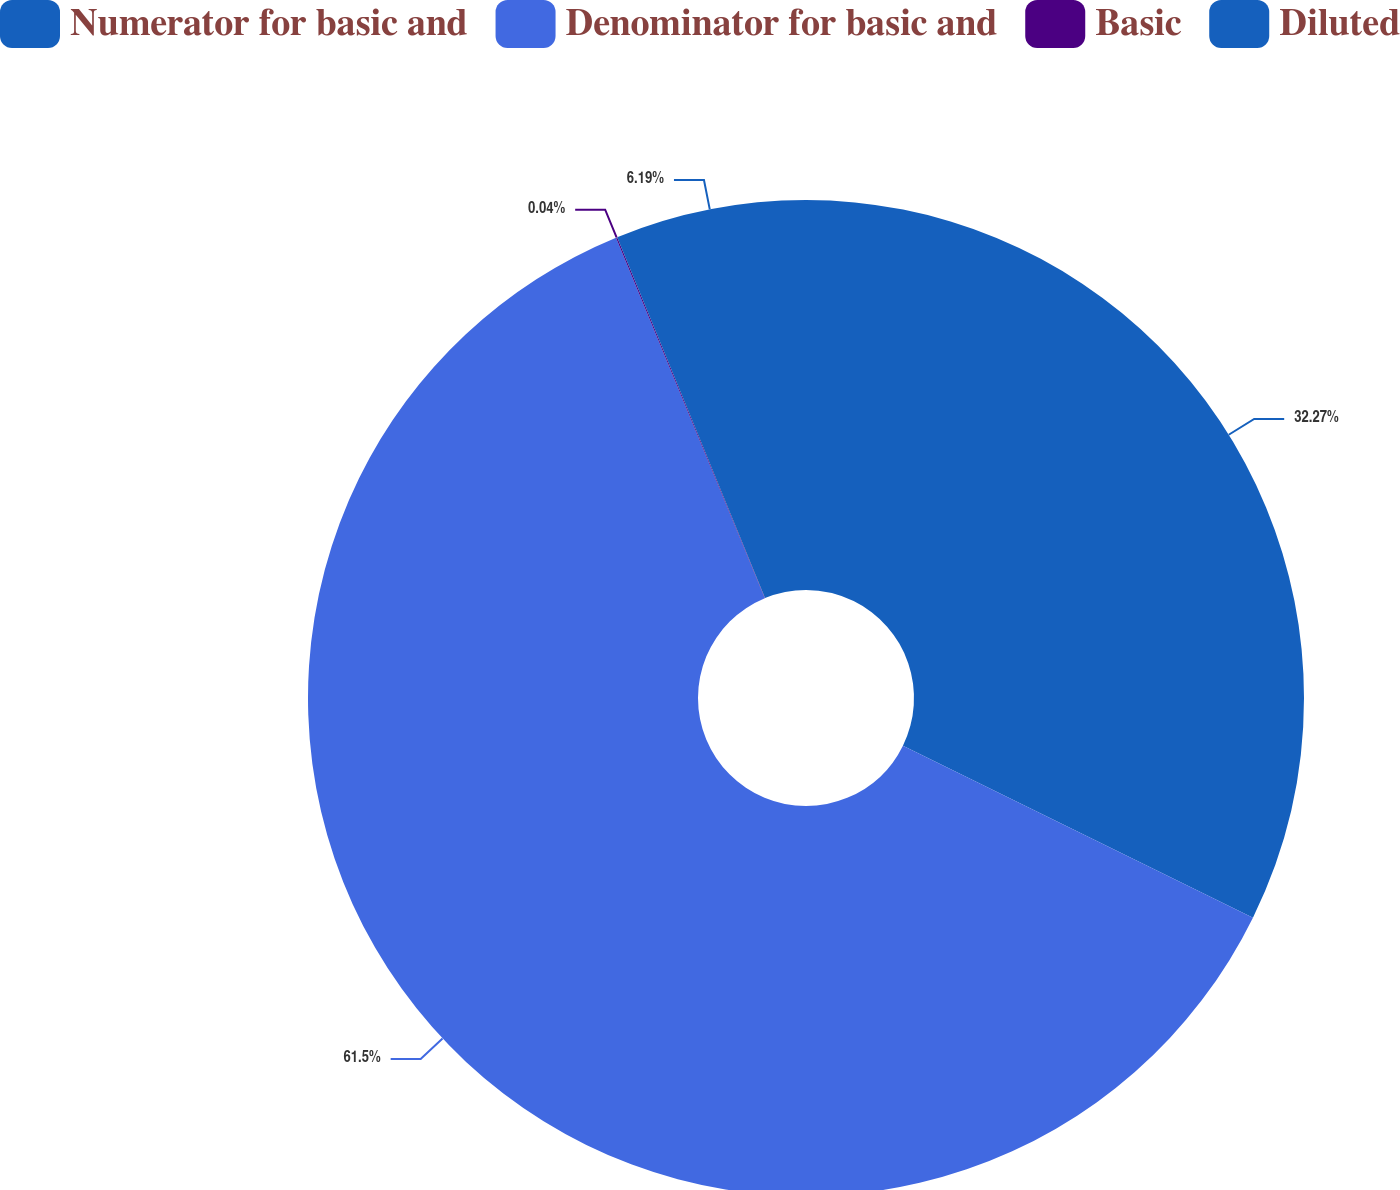<chart> <loc_0><loc_0><loc_500><loc_500><pie_chart><fcel>Numerator for basic and<fcel>Denominator for basic and<fcel>Basic<fcel>Diluted<nl><fcel>32.27%<fcel>61.5%<fcel>0.04%<fcel>6.19%<nl></chart> 